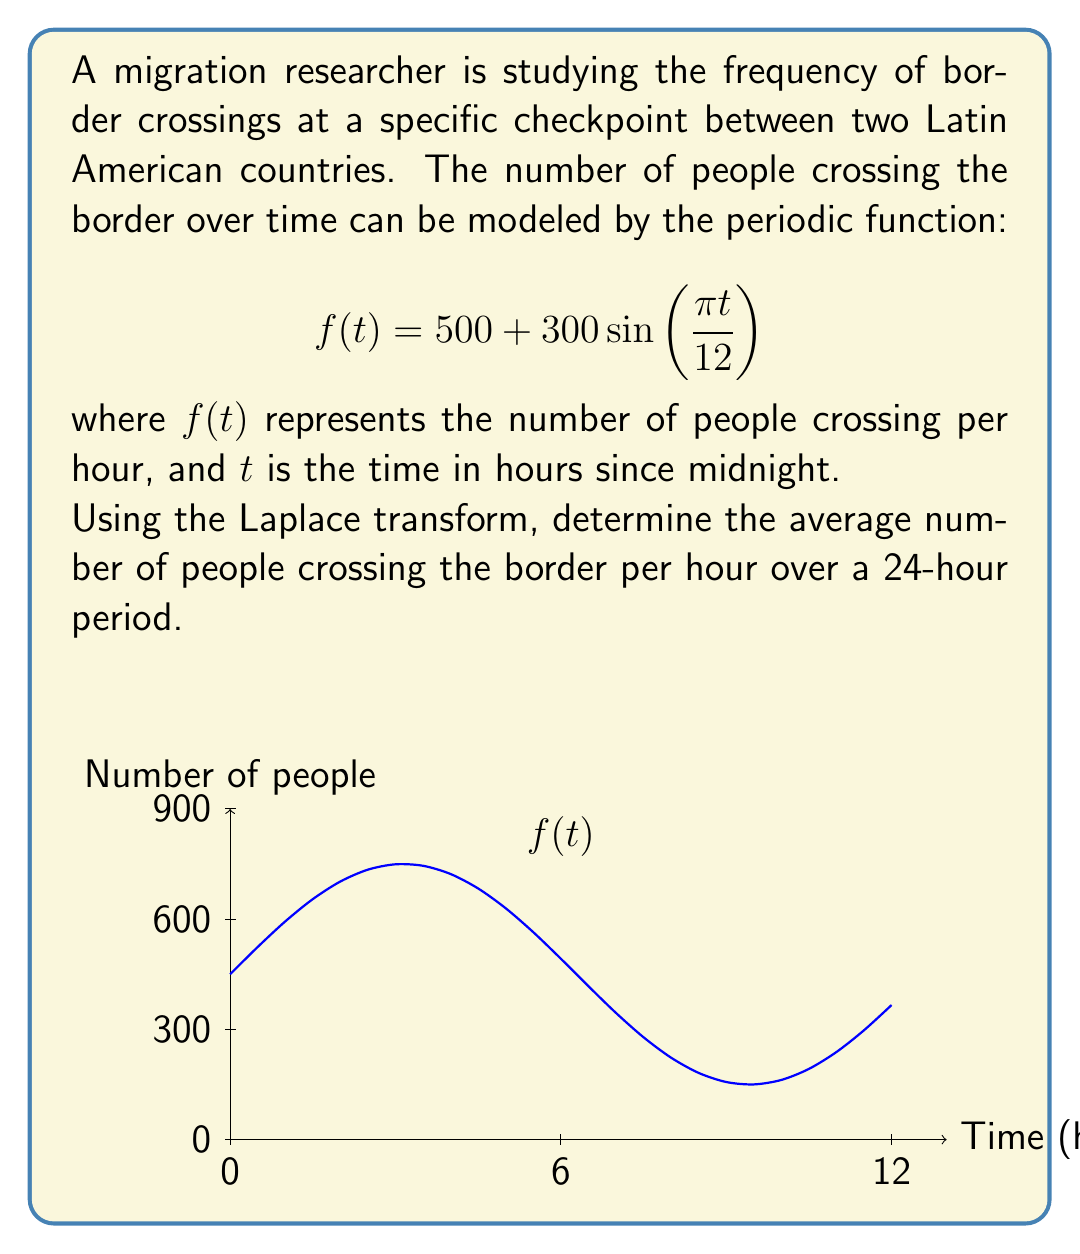Teach me how to tackle this problem. To solve this problem using the Laplace transform, we'll follow these steps:

1) The Laplace transform of a periodic function with period $T$ is given by:

   $$\mathcal{L}\{f(t)\} = \frac{1}{1-e^{-sT}} \int_0^T f(t)e^{-st}dt$$

2) In our case, the period $T = 24$ hours. We need to calculate:

   $$F(s) = \frac{1}{1-e^{-24s}} \int_0^{24} (500 + 300\sin(\frac{\pi t}{12}))e^{-st}dt$$

3) To find the average, we'll use the Final Value Theorem:

   $$\lim_{t \to \infty} f(t) = \lim_{s \to 0} sF(s)$$

4) Applying this:

   $$\text{Average} = \lim_{s \to 0} s \cdot \frac{1}{1-e^{-24s}} \int_0^{24} (500 + 300\sin(\frac{\pi t}{12}))e^{-st}dt$$

5) As $s \to 0$, $e^{-24s} \to 1$, so $\frac{1}{1-e^{-24s}} \to \frac{1}{24}$

6) Also, as $s \to 0$, $e^{-st} \to 1$ for $t \in [0,24]$

7) Therefore, our expression simplifies to:

   $$\text{Average} = \frac{1}{24} \int_0^{24} (500 + 300\sin(\frac{\pi t}{12}))dt$$

8) Integrating:

   $$\text{Average} = \frac{1}{24} [500t - \frac{3600}{\pi}\cos(\frac{\pi t}{12})]_0^{24}$$

9) Evaluating:

   $$\text{Average} = \frac{1}{24} [(500 \cdot 24) - \frac{3600}{\pi}(\cos(2\pi) - \cos(0))]$$

10) Since $\cos(2\pi) = \cos(0) = 1$, the cosine terms cancel out:

    $$\text{Average} = \frac{500 \cdot 24}{24} = 500$$

Therefore, the average number of people crossing the border per hour over a 24-hour period is 500.
Answer: 500 people per hour 